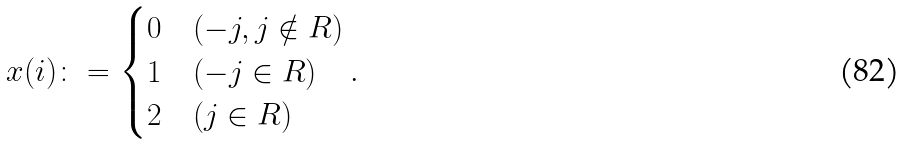<formula> <loc_0><loc_0><loc_500><loc_500>x ( i ) \colon = \begin{cases} 0 & ( - j , j \notin R ) \\ 1 & ( - j \in R ) \\ 2 & ( j \in R ) \end{cases} .</formula> 